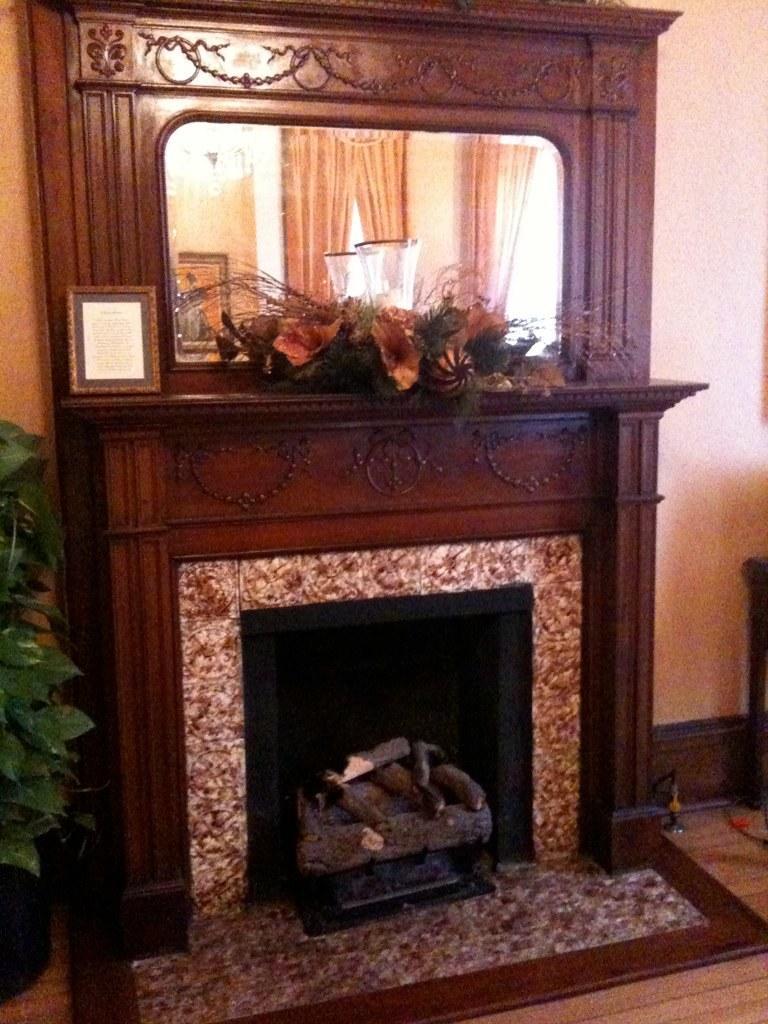Describe this image in one or two sentences. In this picture there are flowers and there is a flower vase and there is a frame on the top of the fireplace and there is a mirror and there is reflection of curtains, frame and lights. On the left side of the image there is a plant in the pot. On the right side of the image there is an object. At the back there is wall. At the bottom there is a floor. 